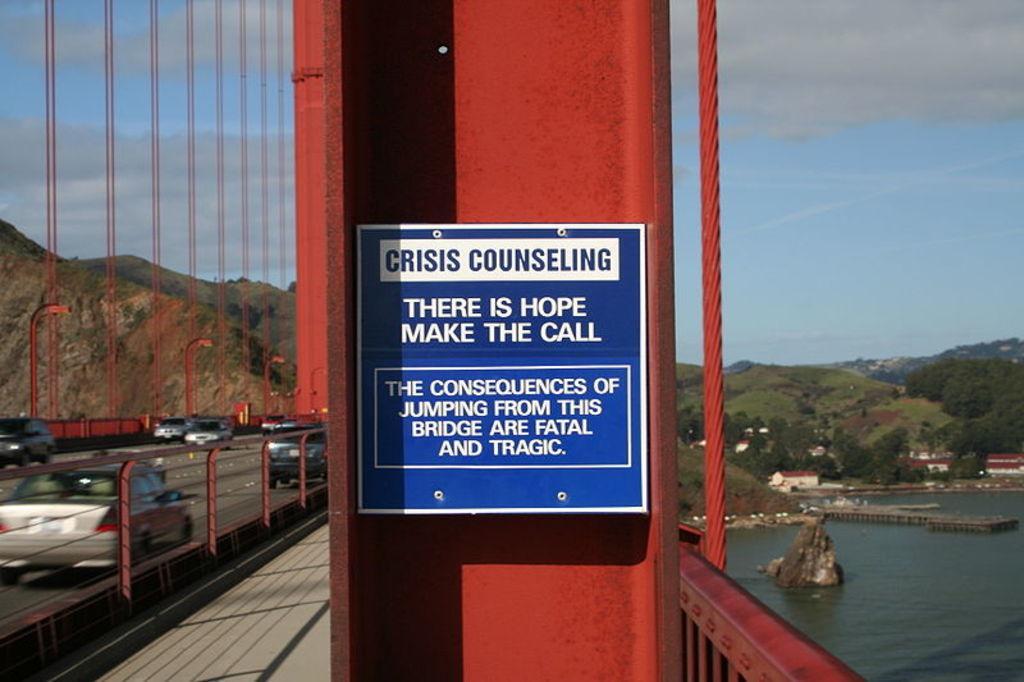Could you give a brief overview of what you see in this image? In this picture I can see many cars and vehicles running on the bridge. In the center I can see the sign boards on this red steel pole. Beside that I can see the steel wire and fencing. In the background I can see the mountains, trees, plants and buildings. In the bottom right corner I can see the river. In the top right corner I can see the sky and clouds. 